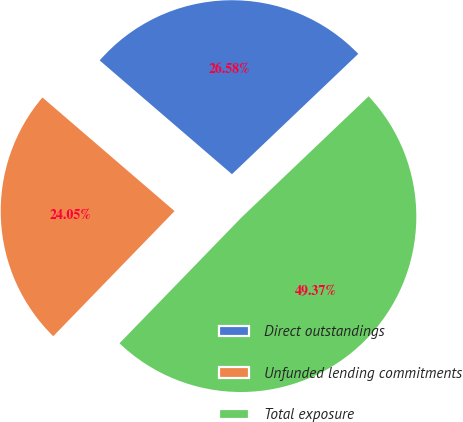<chart> <loc_0><loc_0><loc_500><loc_500><pie_chart><fcel>Direct outstandings<fcel>Unfunded lending commitments<fcel>Total exposure<nl><fcel>26.58%<fcel>24.05%<fcel>49.37%<nl></chart> 